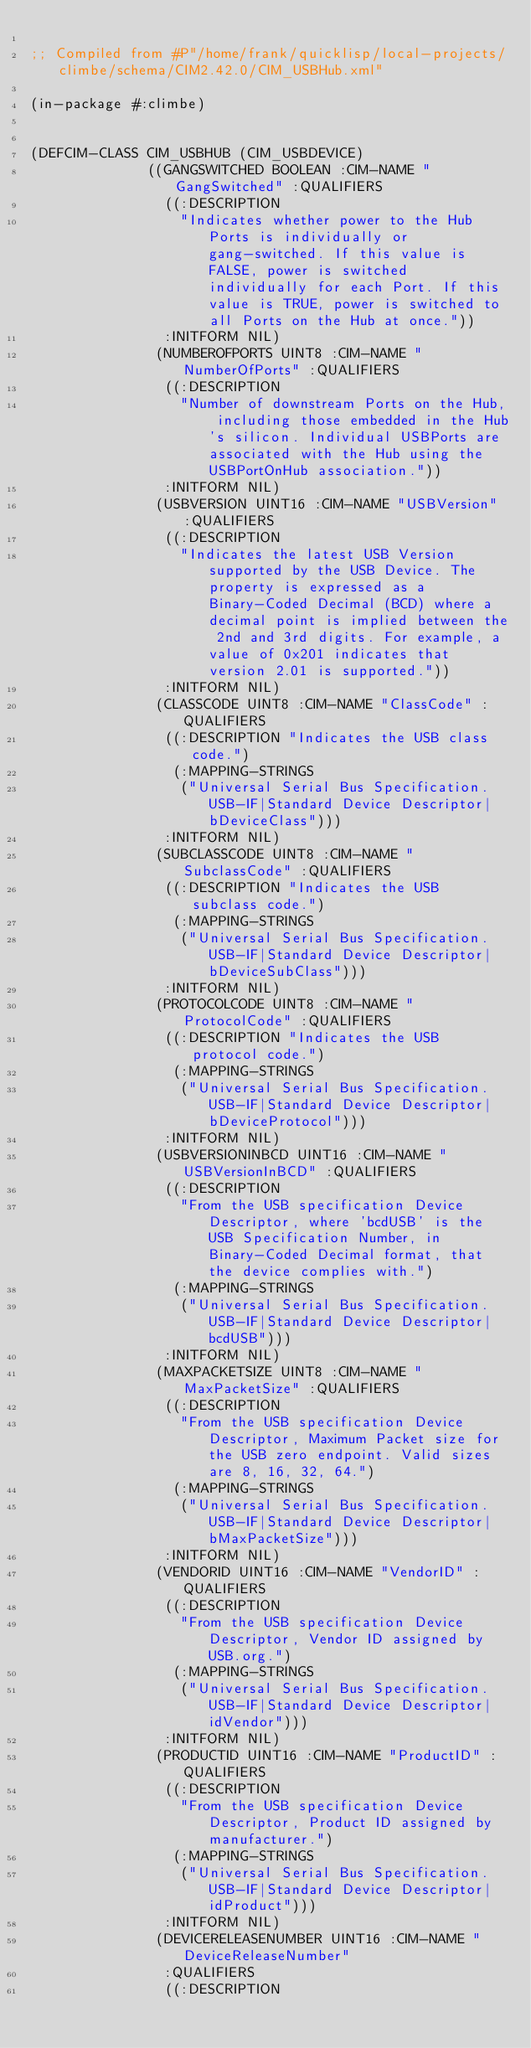<code> <loc_0><loc_0><loc_500><loc_500><_Lisp_>
;; Compiled from #P"/home/frank/quicklisp/local-projects/climbe/schema/CIM2.42.0/CIM_USBHub.xml"

(in-package #:climbe)


(DEFCIM-CLASS CIM_USBHUB (CIM_USBDEVICE)
              ((GANGSWITCHED BOOLEAN :CIM-NAME "GangSwitched" :QUALIFIERS
                ((:DESCRIPTION
                  "Indicates whether power to the Hub Ports is individually or gang-switched. If this value is FALSE, power is switched individually for each Port. If this value is TRUE, power is switched to all Ports on the Hub at once."))
                :INITFORM NIL)
               (NUMBEROFPORTS UINT8 :CIM-NAME "NumberOfPorts" :QUALIFIERS
                ((:DESCRIPTION
                  "Number of downstream Ports on the Hub, including those embedded in the Hub's silicon. Individual USBPorts are associated with the Hub using the USBPortOnHub association."))
                :INITFORM NIL)
               (USBVERSION UINT16 :CIM-NAME "USBVersion" :QUALIFIERS
                ((:DESCRIPTION
                  "Indicates the latest USB Version supported by the USB Device. The property is expressed as a Binary-Coded Decimal (BCD) where a decimal point is implied between the 2nd and 3rd digits. For example, a value of 0x201 indicates that version 2.01 is supported."))
                :INITFORM NIL)
               (CLASSCODE UINT8 :CIM-NAME "ClassCode" :QUALIFIERS
                ((:DESCRIPTION "Indicates the USB class code.")
                 (:MAPPING-STRINGS
                  ("Universal Serial Bus Specification.USB-IF|Standard Device Descriptor|bDeviceClass")))
                :INITFORM NIL)
               (SUBCLASSCODE UINT8 :CIM-NAME "SubclassCode" :QUALIFIERS
                ((:DESCRIPTION "Indicates the USB subclass code.")
                 (:MAPPING-STRINGS
                  ("Universal Serial Bus Specification.USB-IF|Standard Device Descriptor|bDeviceSubClass")))
                :INITFORM NIL)
               (PROTOCOLCODE UINT8 :CIM-NAME "ProtocolCode" :QUALIFIERS
                ((:DESCRIPTION "Indicates the USB protocol code.")
                 (:MAPPING-STRINGS
                  ("Universal Serial Bus Specification.USB-IF|Standard Device Descriptor|bDeviceProtocol")))
                :INITFORM NIL)
               (USBVERSIONINBCD UINT16 :CIM-NAME "USBVersionInBCD" :QUALIFIERS
                ((:DESCRIPTION
                  "From the USB specification Device Descriptor, where 'bcdUSB' is the USB Specification Number, in Binary-Coded Decimal format, that the device complies with.")
                 (:MAPPING-STRINGS
                  ("Universal Serial Bus Specification.USB-IF|Standard Device Descriptor|bcdUSB")))
                :INITFORM NIL)
               (MAXPACKETSIZE UINT8 :CIM-NAME "MaxPacketSize" :QUALIFIERS
                ((:DESCRIPTION
                  "From the USB specification Device Descriptor, Maximum Packet size for the USB zero endpoint. Valid sizes are 8, 16, 32, 64.")
                 (:MAPPING-STRINGS
                  ("Universal Serial Bus Specification.USB-IF|Standard Device Descriptor|bMaxPacketSize")))
                :INITFORM NIL)
               (VENDORID UINT16 :CIM-NAME "VendorID" :QUALIFIERS
                ((:DESCRIPTION
                  "From the USB specification Device Descriptor, Vendor ID assigned by USB.org.")
                 (:MAPPING-STRINGS
                  ("Universal Serial Bus Specification.USB-IF|Standard Device Descriptor|idVendor")))
                :INITFORM NIL)
               (PRODUCTID UINT16 :CIM-NAME "ProductID" :QUALIFIERS
                ((:DESCRIPTION
                  "From the USB specification Device Descriptor, Product ID assigned by manufacturer.")
                 (:MAPPING-STRINGS
                  ("Universal Serial Bus Specification.USB-IF|Standard Device Descriptor|idProduct")))
                :INITFORM NIL)
               (DEVICERELEASENUMBER UINT16 :CIM-NAME "DeviceReleaseNumber"
                :QUALIFIERS
                ((:DESCRIPTION</code> 